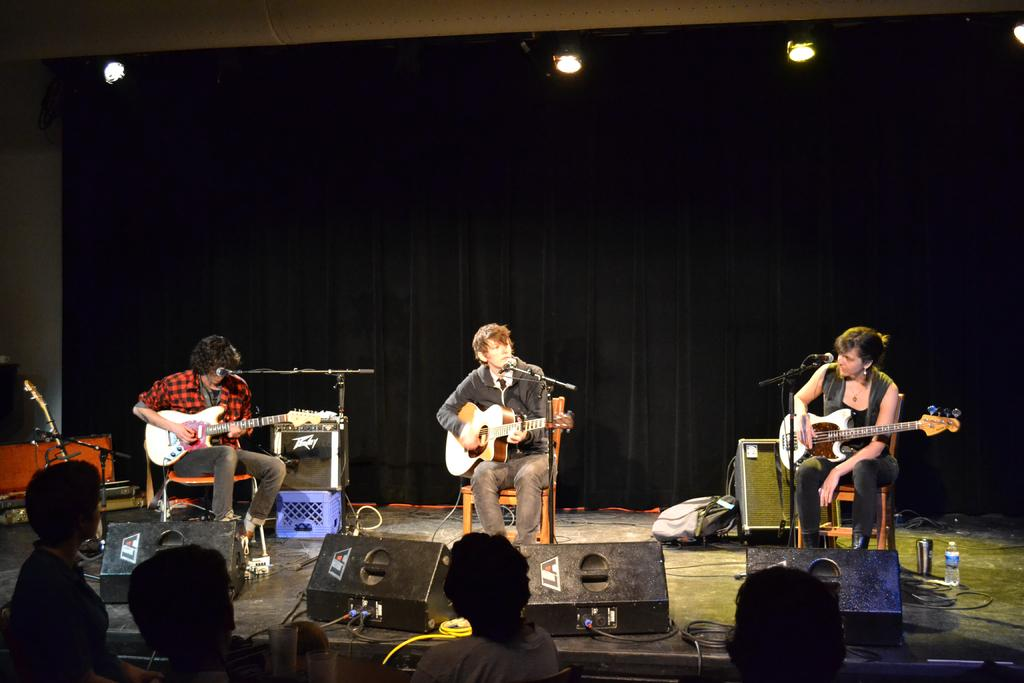How many people are in the image? There are three guys in the image. What are the guys doing in the image? The guys are playing guitar. What object is in front of them? There is a microphone in front of them. What color is the background of the image? The background of the image is black. Can you hear the sound of bells in the image? There is no sound present in the image, so it is not possible to hear any bells. 